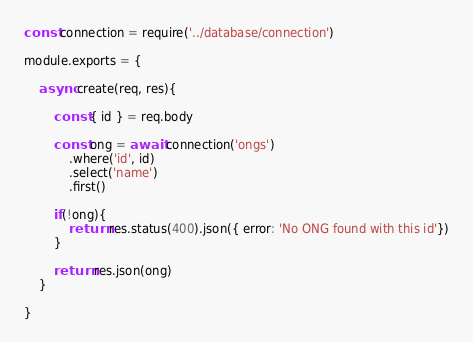Convert code to text. <code><loc_0><loc_0><loc_500><loc_500><_JavaScript_>const connection = require('../database/connection')

module.exports = {

    async create(req, res){

        const { id } = req.body

        const ong = await connection('ongs')
            .where('id', id)
            .select('name')
            .first()
        
        if(!ong){
            return res.status(400).json({ error: 'No ONG found with this id'})
        }

        return res.json(ong)
    }

}</code> 